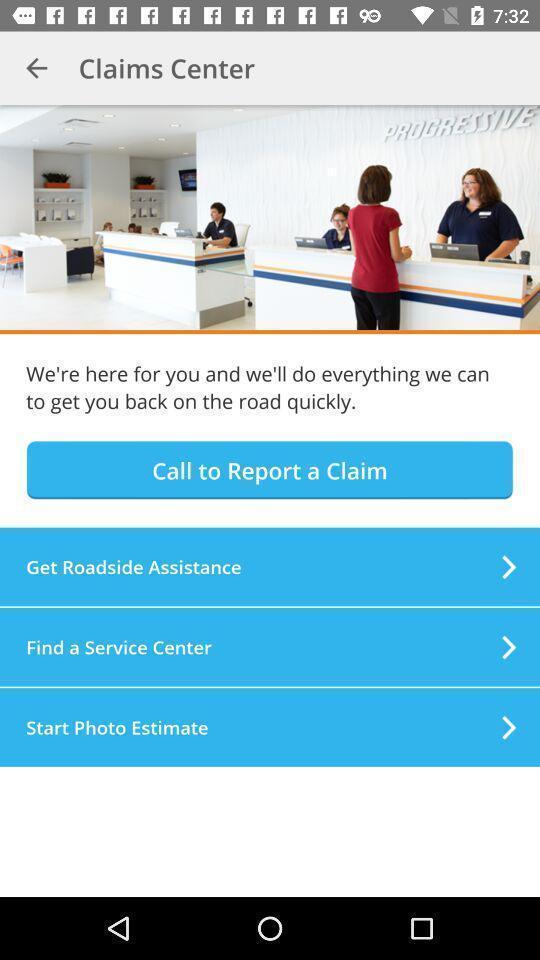Tell me about the visual elements in this screen capture. Page showing multiple options. 